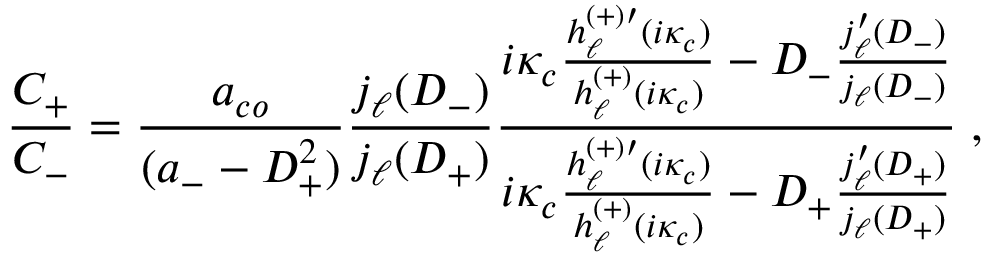Convert formula to latex. <formula><loc_0><loc_0><loc_500><loc_500>\frac { C _ { + } } { C _ { - } } = \frac { a _ { c o } } { ( a _ { - } - D _ { + } ^ { 2 } ) } \frac { j _ { \ell } ( D _ { - } ) } { j _ { \ell } ( D _ { + } ) } \frac { i \kappa _ { c } \frac { h _ { \ell } ^ { ( + ) \prime } ( i \kappa _ { c } ) } { h _ { \ell } ^ { ( + ) } ( i \kappa _ { c } ) } - D _ { - } \frac { j _ { \ell } ^ { \prime } ( D _ { - } ) } { j _ { \ell } ( D _ { - } ) } } { i \kappa _ { c } \frac { h _ { \ell } ^ { ( + ) \prime } ( i \kappa _ { c } ) } { h _ { \ell } ^ { ( + ) } ( i \kappa _ { c } ) } - D _ { + } \frac { j _ { \ell } ^ { \prime } ( D _ { + } ) } { j _ { \ell } ( D _ { + } ) } } \, ,</formula> 